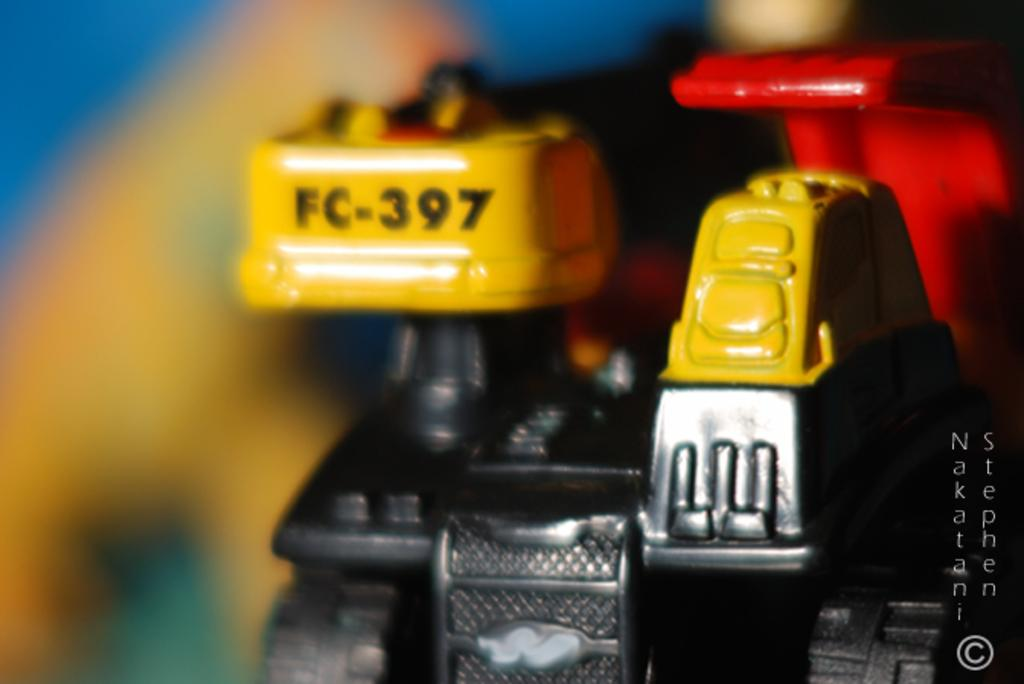<image>
Summarize the visual content of the image. A piece of equipment numbered FC-397 on the top of the yellow piece. 